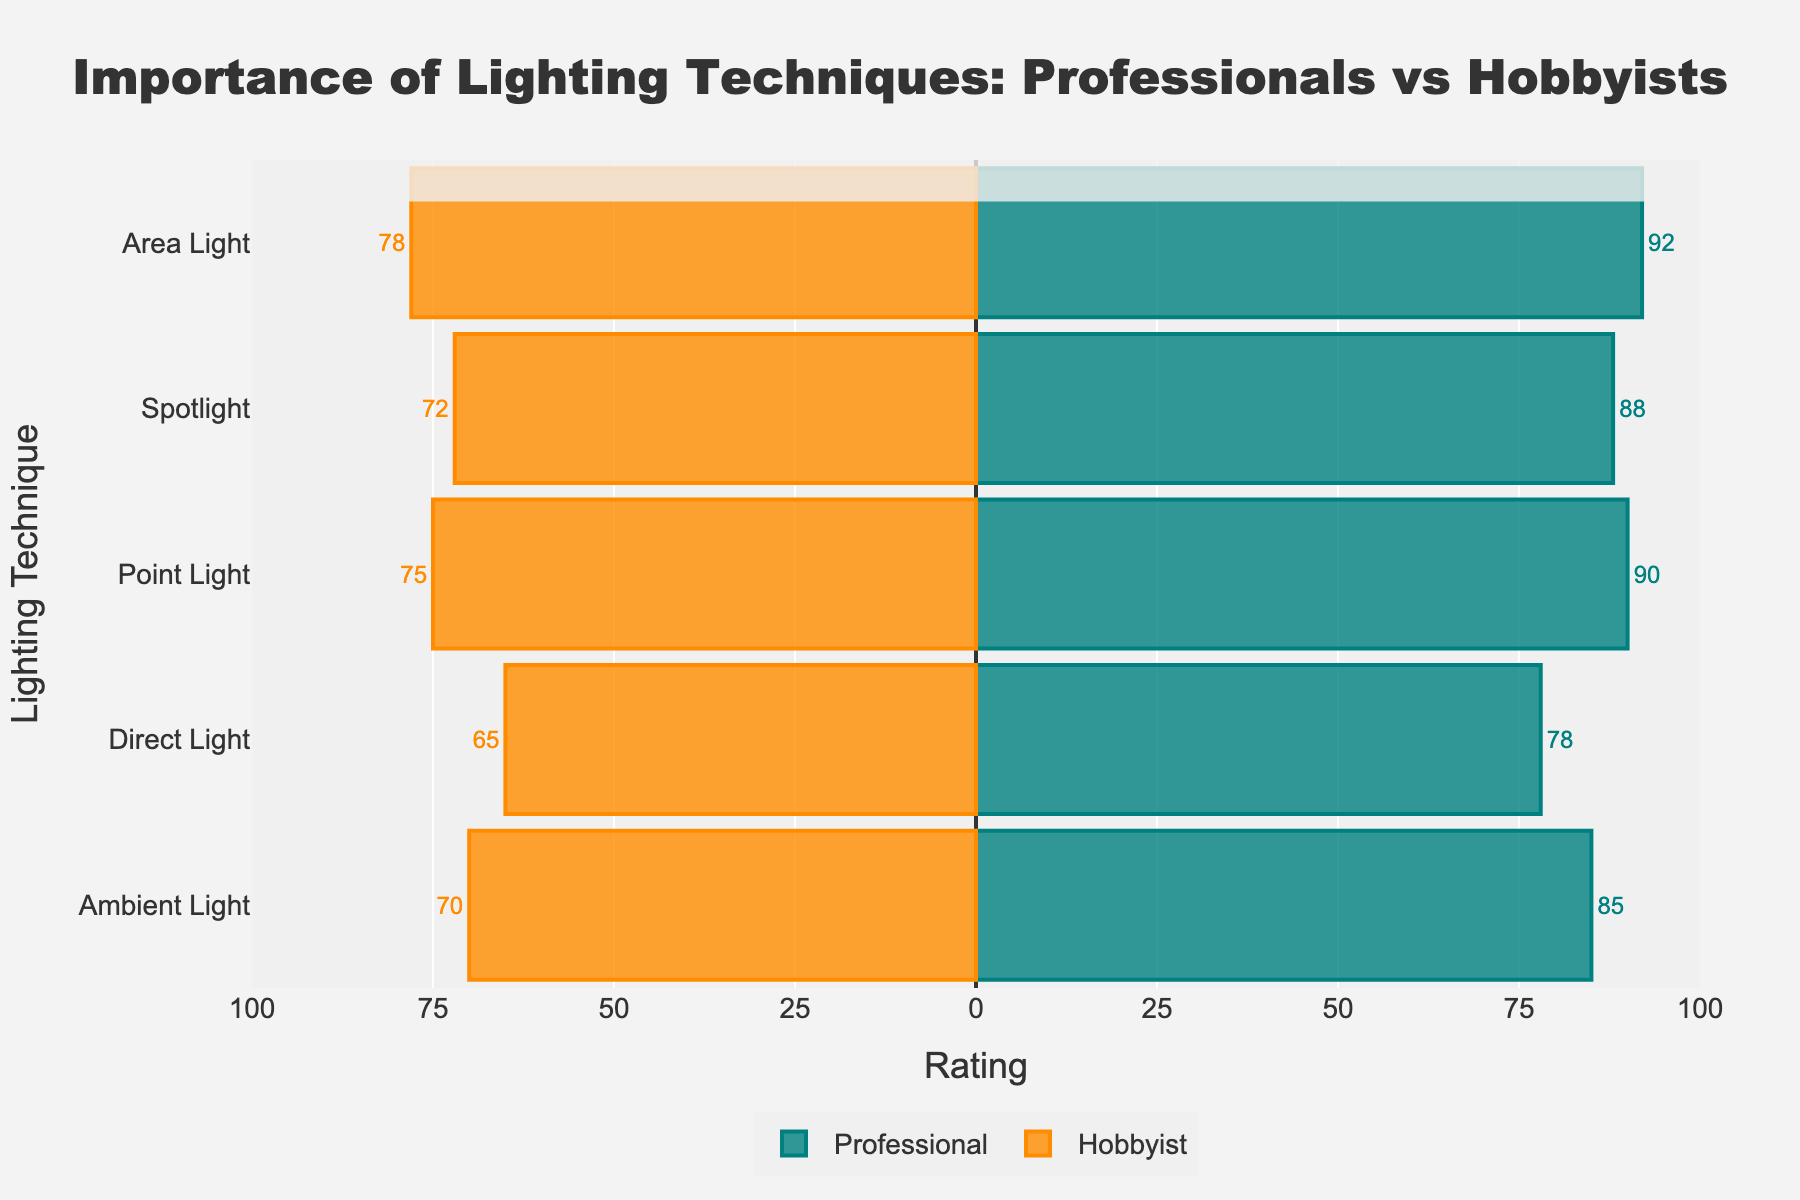What lighting technique is rated the highest by professionals? Look at the bars on the right side. The 'Area Light' bar extends the furthest to the right with a rating of 92.
Answer: Area Light What is the difference in the ratings of Direct Light between professionals and hobbyists? Find the lengths of the 'Direct Light' bars for both professionals and hobbyists. The professional rating is 78, and the hobbyist rating is 65. The difference is 78 - 65.
Answer: 13 Which lighting technique has the smallest difference in ratings between professionals and hobbyists? Subtract the hobbyist ratings from the professional ratings for each technique and find the smallest difference. The smallest difference is for 'Ambient Light' (85-70=15).
Answer: Ambient Light What is the average rating of Point Light for both professionals and hobbyists combined? The ratings for Point Light are 90 (professional) and 75 (hobbyist). Sum them and divide by 2: (90 + 75)/2 = 82.5.
Answer: 82.5 Which lighting technique has the largest gap in ratings between professionals and hobbyists? Calculate the differences: Ambient Light (15), Direct Light (13), Point Light (15), Spotlight (16), Area Light (14). The largest gap is for 'Spotlight' with a difference of 16.
Answer: Spotlight Rank the lighting techniques based on professional ratings from highest to lowest. Look at the lengths of the professional bars: Area Light (92), Point Light (90), Spotlight (88), Ambient Light (85), Direct Light (78).
Answer: Area Light, Point Light, Spotlight, Ambient Light, Direct Light What is the overall rating trend observed for hobbyists compared to professionals? Except for each lighting technique, compare the hobbyist bars (left negative side) which are consistently shorter than the professional bars (right positive side). This indicates lower ratings by hobbyists.
Answer: Hobbyists rate lighting techniques lower than professionals How do the ratings for Ambient Light compare between professionals and hobbyists in terms of absolute rating difference? The professional rating for Ambient Light is 85 and for hobbyists is 70. The absolute difference is:
Answer: 85 - 70 = 15 